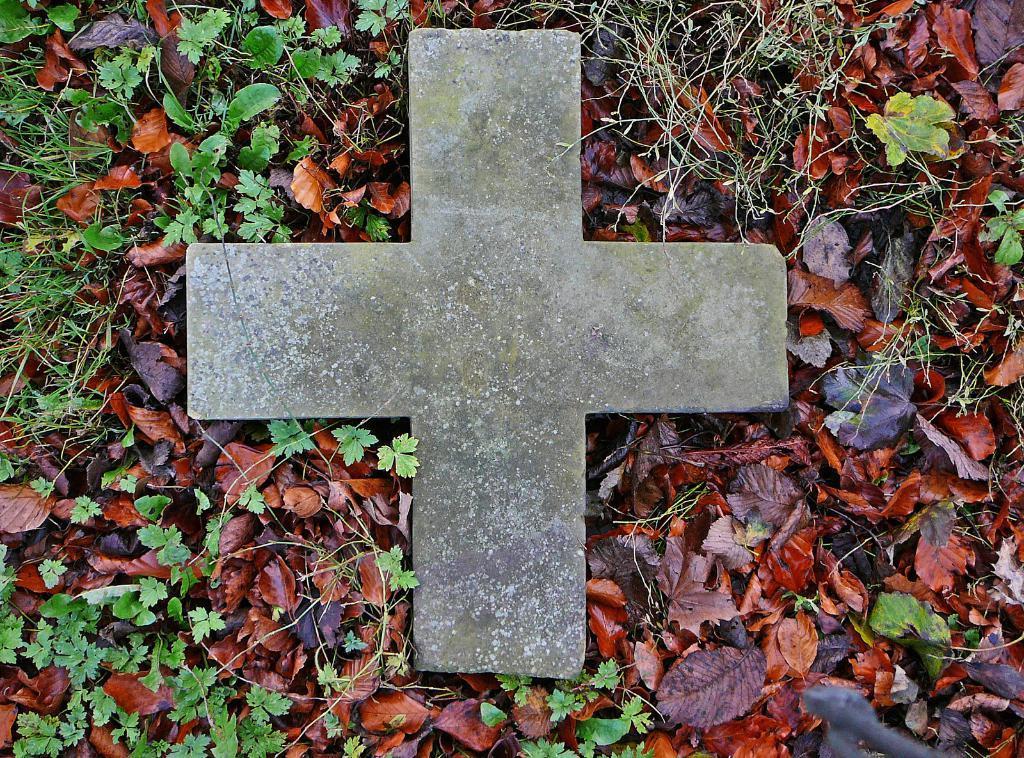In one or two sentences, can you explain what this image depicts? In the center of the image there is a stone in a shape of a cross. At the bottom there are leaves and grass. 